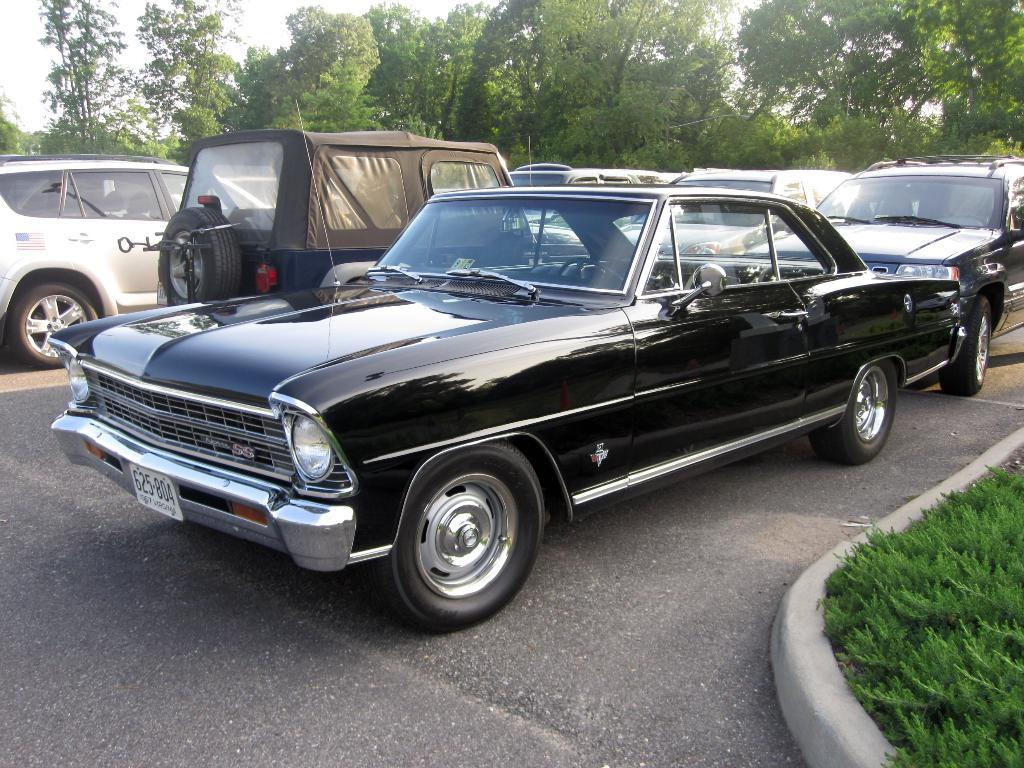What is present on the road in the image? There are vehicles on the road in the image. What can be seen in the background of the image? There are trees and the sky visible in the background of the image. What type of ink is being used to draw on the plate in the image? There is no plate or ink present in the image. Can you tell me how many uncles are visible in the image? There are no people, including uncles, present in the image. 